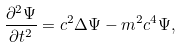<formula> <loc_0><loc_0><loc_500><loc_500>\frac { \partial ^ { 2 } \Psi } { \partial t ^ { 2 } } = c ^ { 2 } \Delta \Psi - m ^ { 2 } c ^ { 4 } \Psi ,</formula> 